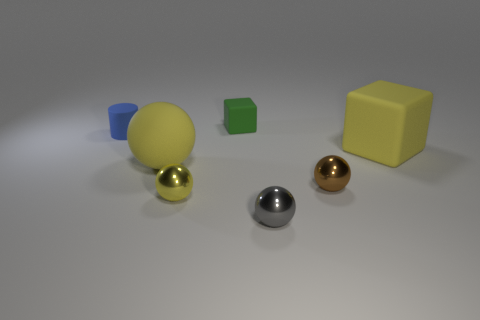Subtract all gray spheres. How many spheres are left? 3 Subtract 4 spheres. How many spheres are left? 0 Add 3 big spheres. How many objects exist? 10 Subtract all brown spheres. How many spheres are left? 3 Subtract all cubes. How many objects are left? 5 Add 5 cyan spheres. How many cyan spheres exist? 5 Subtract 0 gray cylinders. How many objects are left? 7 Subtract all gray cubes. Subtract all cyan spheres. How many cubes are left? 2 Subtract all blue spheres. How many green blocks are left? 1 Subtract all red cylinders. Subtract all small balls. How many objects are left? 4 